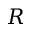Convert formula to latex. <formula><loc_0><loc_0><loc_500><loc_500>R</formula> 